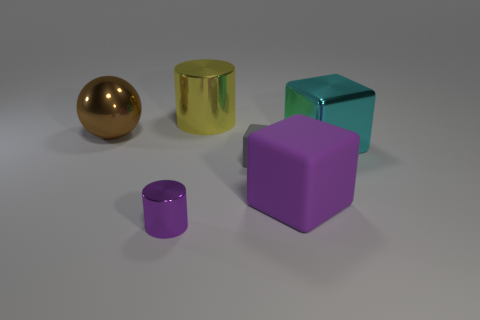Add 1 gray matte cylinders. How many objects exist? 7 Subtract all balls. How many objects are left? 5 Add 6 small blue metallic objects. How many small blue metallic objects exist? 6 Subtract 0 yellow spheres. How many objects are left? 6 Subtract all small red metal objects. Subtract all large brown metal balls. How many objects are left? 5 Add 4 big brown metal objects. How many big brown metal objects are left? 5 